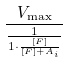Convert formula to latex. <formula><loc_0><loc_0><loc_500><loc_500>\frac { V _ { \max } } { \frac { 1 } { 1 \cdot \frac { [ F ] } { [ F ] + A _ { i } } } }</formula> 